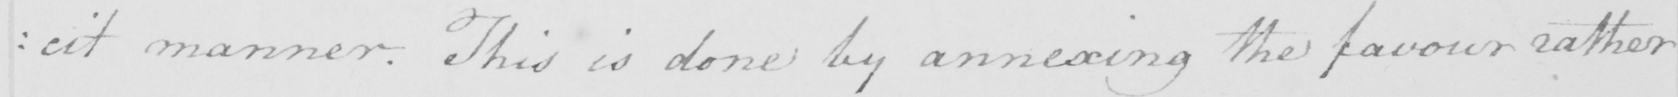What is written in this line of handwriting? : cit manner . This is done by annexing the favour rather 